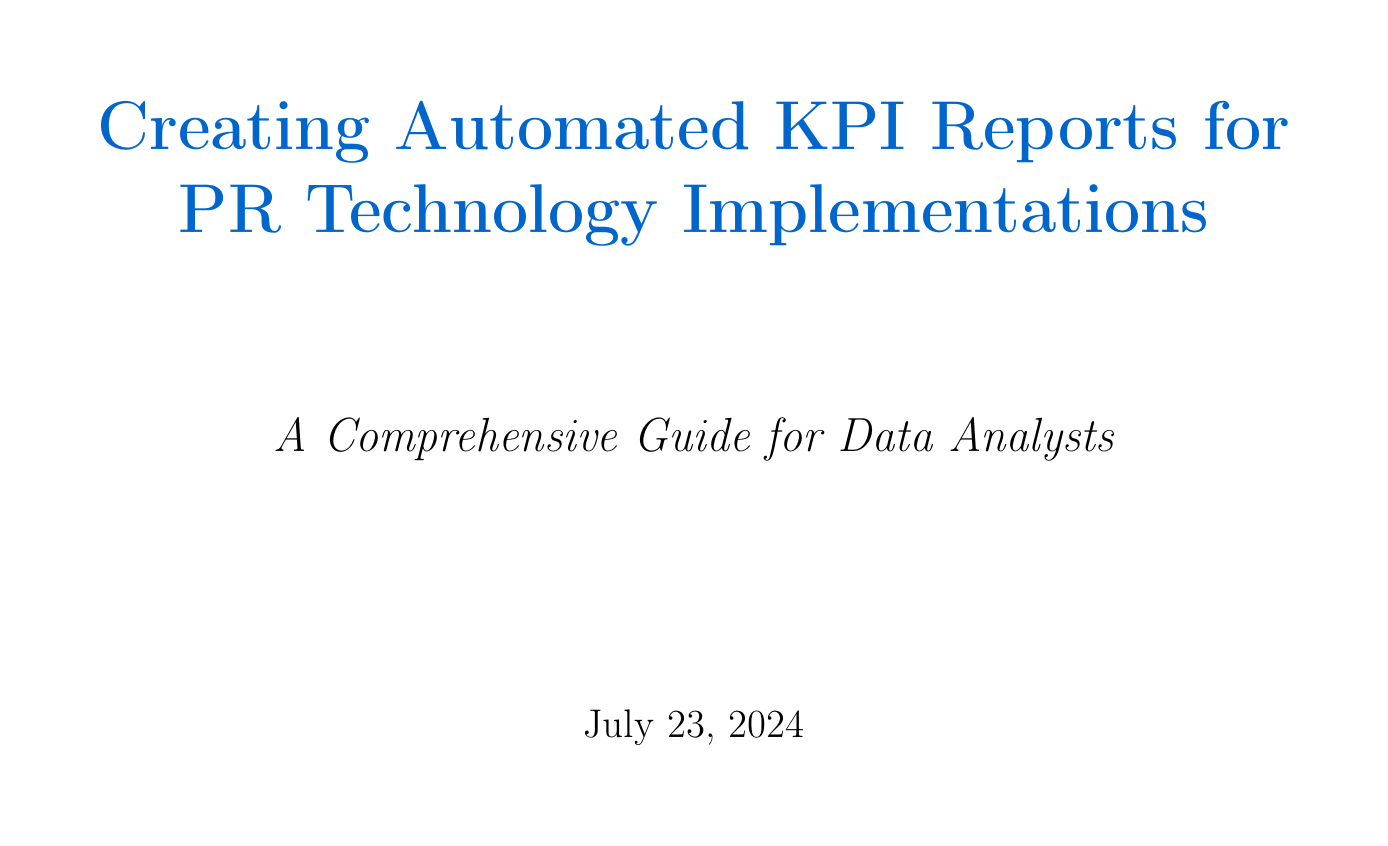What is the main focus of the tutorial? The main focus of the tutorial is to guide users through the process of creating automated reports to monitor the performance of PR technology implementations across various client campaigns.
Answer: automated reports for tracking KPIs What is a key metric for PR technology implementations? One of the key metrics listed in the document for PR technology implementations is media mentions.
Answer: media mentions Which PR tool is recommended for data visualization? The document recommends Tableau as a data visualization platform for PR technology tools.
Answer: Tableau What is one of the elements to include in report templates? One of the elements to include in report templates is an executive summary dashboard.
Answer: executive summary dashboard What is a challenge faced by Acme Corp? The document notes initial challenges faced by Acme Corp in their PR tech implementation.
Answer: initial challenges What will help optimize report load times? Addressing common issues such as dealing with API rate limits is crucial to optimize report load times.
Answer: API rate limits What should be developed when creating automated reports? When creating automated reports, data models should be developed to combine information from various PR tools and campaigns.
Answer: data models What future trend involves blockchain? The document mentions blockchain for verified media coverage tracking as a future trend in PR technology reporting.
Answer: verified media coverage tracking What aspect is emphasized in the conclusion? The conclusion emphasizes the importance of continuous learning and adaptation in the fast-paced world of PR technology and data analysis.
Answer: continuous learning and adaptation 